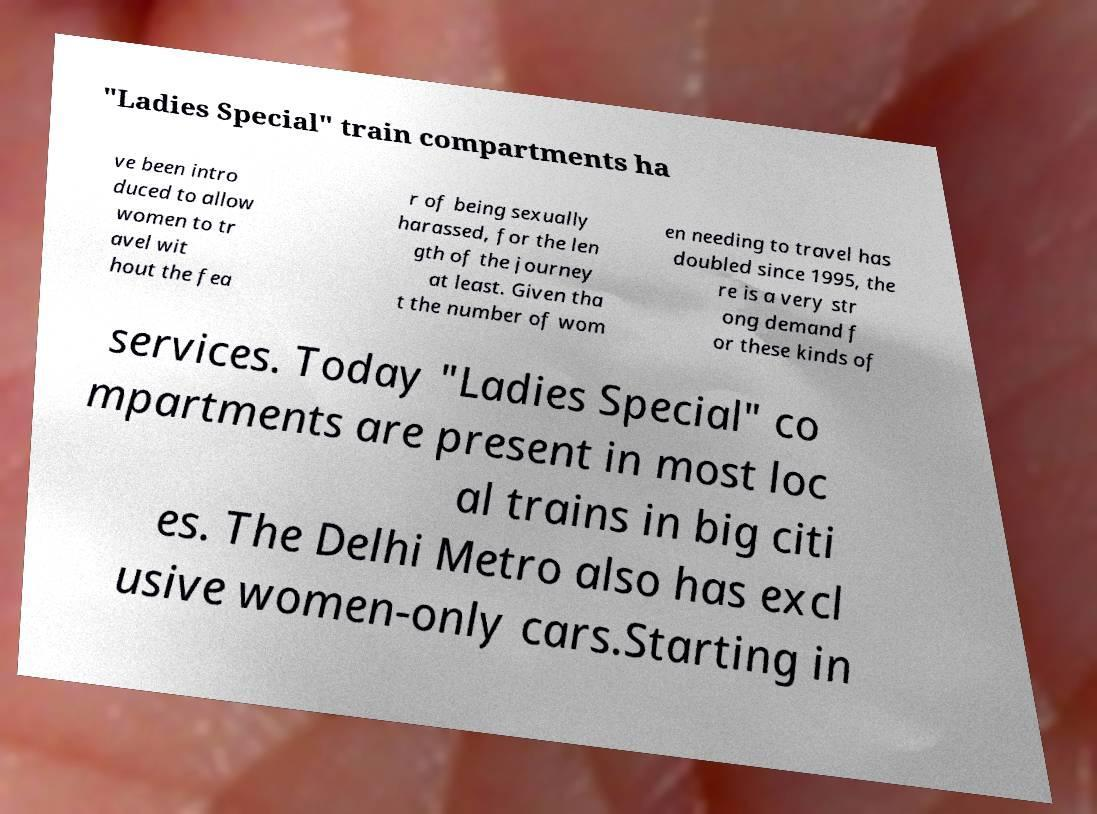Could you assist in decoding the text presented in this image and type it out clearly? "Ladies Special" train compartments ha ve been intro duced to allow women to tr avel wit hout the fea r of being sexually harassed, for the len gth of the journey at least. Given tha t the number of wom en needing to travel has doubled since 1995, the re is a very str ong demand f or these kinds of services. Today "Ladies Special" co mpartments are present in most loc al trains in big citi es. The Delhi Metro also has excl usive women-only cars.Starting in 